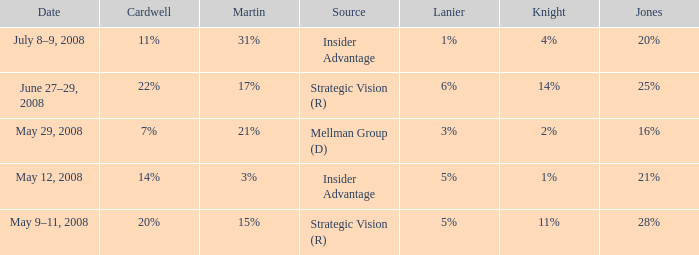What martin is on july 8–9, 2008? 31%. 